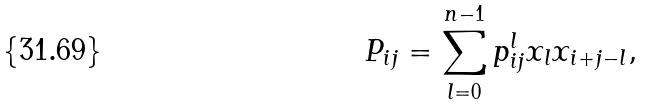<formula> <loc_0><loc_0><loc_500><loc_500>P _ { i j } = \sum _ { l = 0 } ^ { n - 1 } p ^ { l } _ { i j } x _ { l } x _ { i + j - l } ,</formula> 